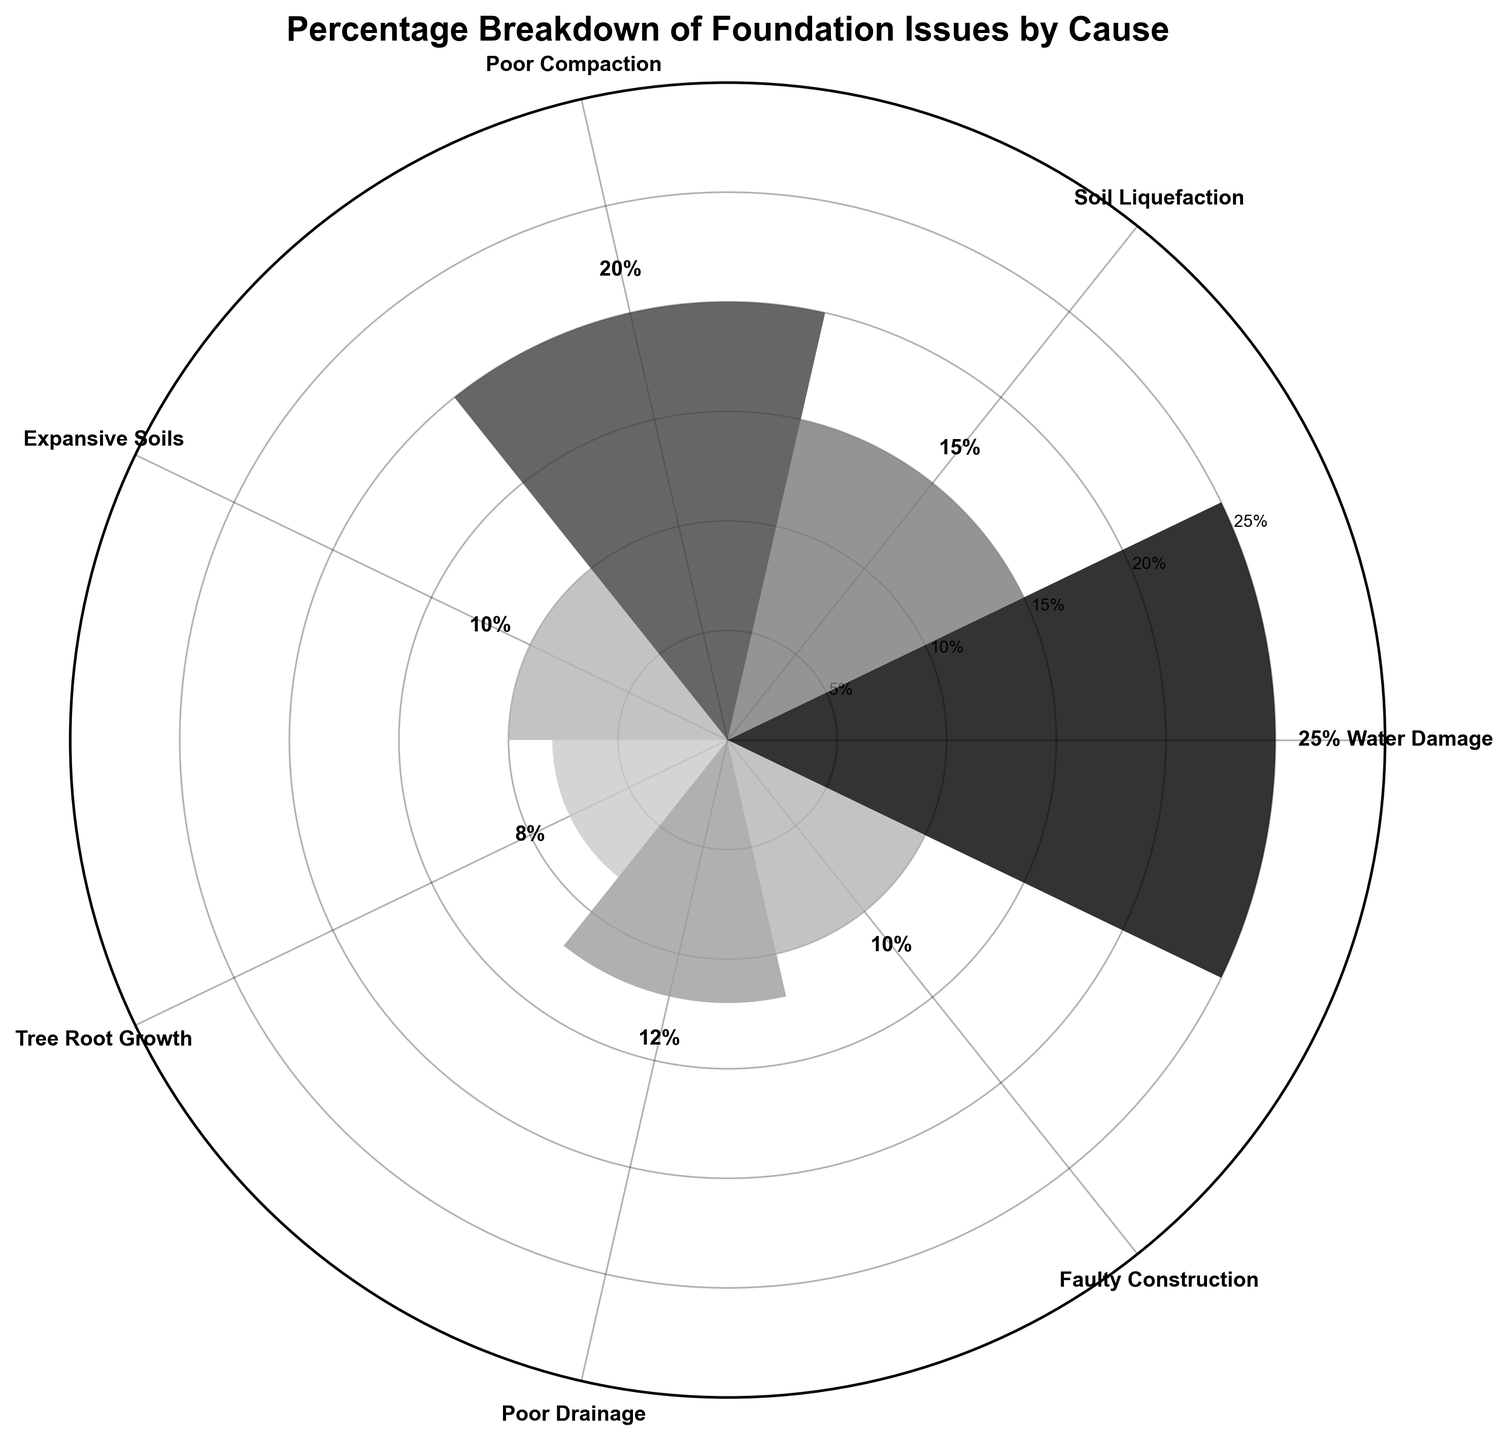What is the highest percentage cause of foundation issues? The highest percentage is found by identifying the tallest bar in the chart, which corresponds to the 'Water Damage' cause.
Answer: Water Damage What is the title of the chart? The title is the text located at the top of the figure. It helps in understanding the overall subject of the chart.
Answer: Percentage Breakdown of Foundation Issues by Cause How many causes are listed in the chart? Count the number of bars, where each bar represents a different cause.
Answer: 7 Which cause has the lowest percentage? The lowest percentage is determined by the shortest bar in the chart, which corresponds to the 'Tree Root Growth' cause.
Answer: Tree Root Growth What percentage of foundation issues are due to Poor Compaction? Locate the bar labeled 'Poor Compaction' and read the percentage value annotated near the top of the bar.
Answer: 20% How much greater is the percentage of Water Damage compared to Tree Root Growth? Subtract the percentage of Tree Root Growth (8%) from the percentage of Water Damage (25%).
Answer: 17% What are the percentages for Expansive Soils and Faulty Construction combined? Sum the percentages for 'Expansive Soils' (10%) and 'Faulty Construction' (10%).
Answer: 20% Which cause has a higher percentage, Poor Drainage or Soil Liquefaction? Compare the heights (and percentages) of the bars labeled 'Poor Drainage' and 'Soil Liquefaction'. Poor Drainage is 12% and Soil Liquefaction is 15%.
Answer: Soil Liquefaction Which cause has the second highest percentage? Identify the second tallest bar. The tallest is 'Water Damage' with 25%, and the next tallest is 'Poor Compaction' with 20%.
Answer: Poor Compaction How many causes have a percentage greater than 10%? Count the bars with heights greater than the 10% mark on the radial axis. These are Water Damage (25%), Poor Compaction (20%), Soil Liquefaction (15%), and Poor Drainage (12%).
Answer: 4 